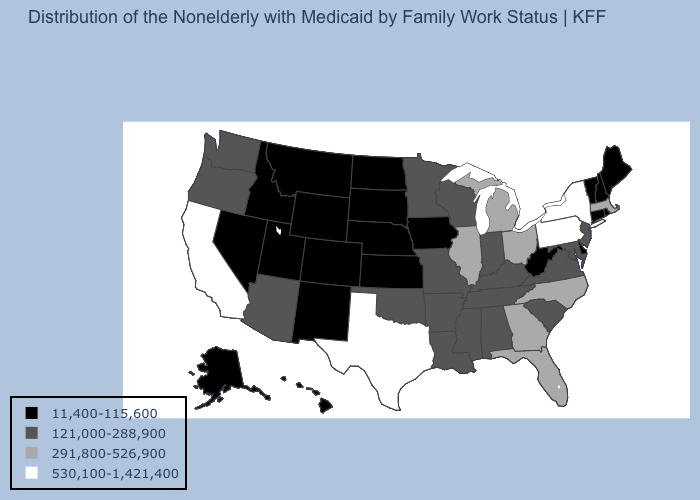What is the value of Michigan?
Quick response, please. 291,800-526,900. Which states have the highest value in the USA?
Concise answer only. California, New York, Pennsylvania, Texas. What is the value of Maryland?
Concise answer only. 121,000-288,900. Which states have the lowest value in the South?
Be succinct. Delaware, West Virginia. Among the states that border North Carolina , which have the highest value?
Answer briefly. Georgia. Does Mississippi have the lowest value in the USA?
Answer briefly. No. Name the states that have a value in the range 121,000-288,900?
Answer briefly. Alabama, Arizona, Arkansas, Indiana, Kentucky, Louisiana, Maryland, Minnesota, Mississippi, Missouri, New Jersey, Oklahoma, Oregon, South Carolina, Tennessee, Virginia, Washington, Wisconsin. Is the legend a continuous bar?
Give a very brief answer. No. Which states have the lowest value in the USA?
Give a very brief answer. Alaska, Colorado, Connecticut, Delaware, Hawaii, Idaho, Iowa, Kansas, Maine, Montana, Nebraska, Nevada, New Hampshire, New Mexico, North Dakota, Rhode Island, South Dakota, Utah, Vermont, West Virginia, Wyoming. What is the value of Wisconsin?
Quick response, please. 121,000-288,900. Name the states that have a value in the range 11,400-115,600?
Concise answer only. Alaska, Colorado, Connecticut, Delaware, Hawaii, Idaho, Iowa, Kansas, Maine, Montana, Nebraska, Nevada, New Hampshire, New Mexico, North Dakota, Rhode Island, South Dakota, Utah, Vermont, West Virginia, Wyoming. Does the first symbol in the legend represent the smallest category?
Be succinct. Yes. Which states hav the highest value in the West?
Write a very short answer. California. Which states have the highest value in the USA?
Answer briefly. California, New York, Pennsylvania, Texas. What is the lowest value in the USA?
Write a very short answer. 11,400-115,600. 